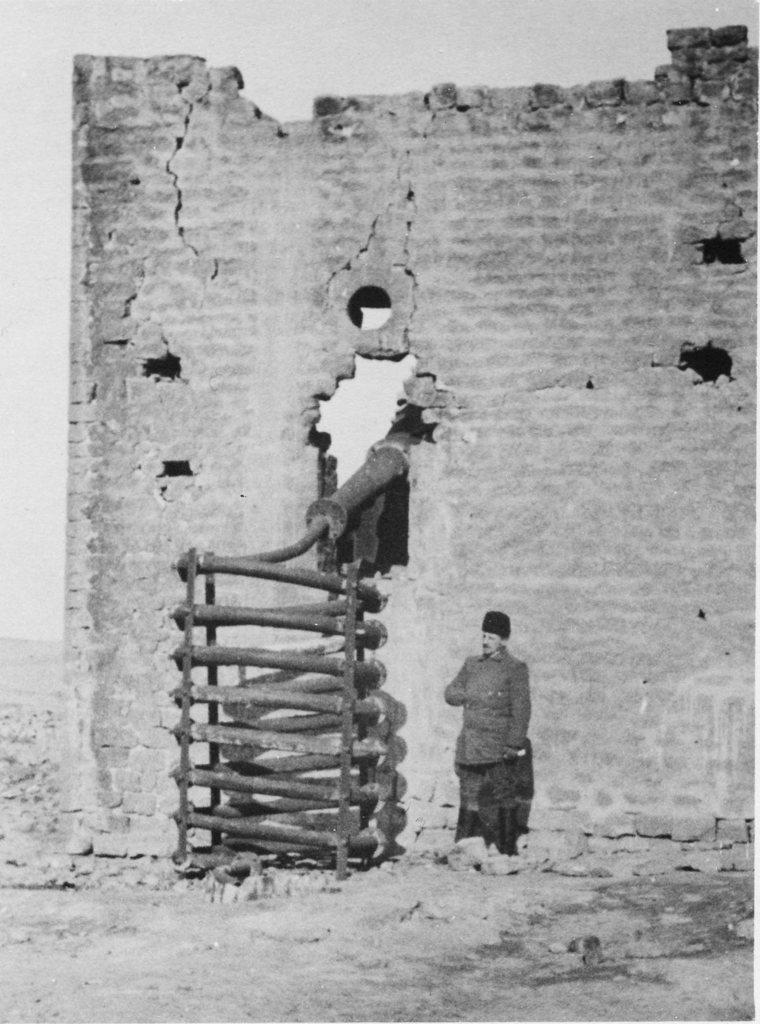What is the main feature in the center of the image? There is a broken wall in the center of the image. Who or what can be seen near the broken wall? There is a man in the center of the image. What else is present in the center of the image? There is a wooden rack in the center of the image. How many silk scarves are hanging on the wooden rack in the image? There is no mention of silk scarves or any other items hanging on the wooden rack in the image. 